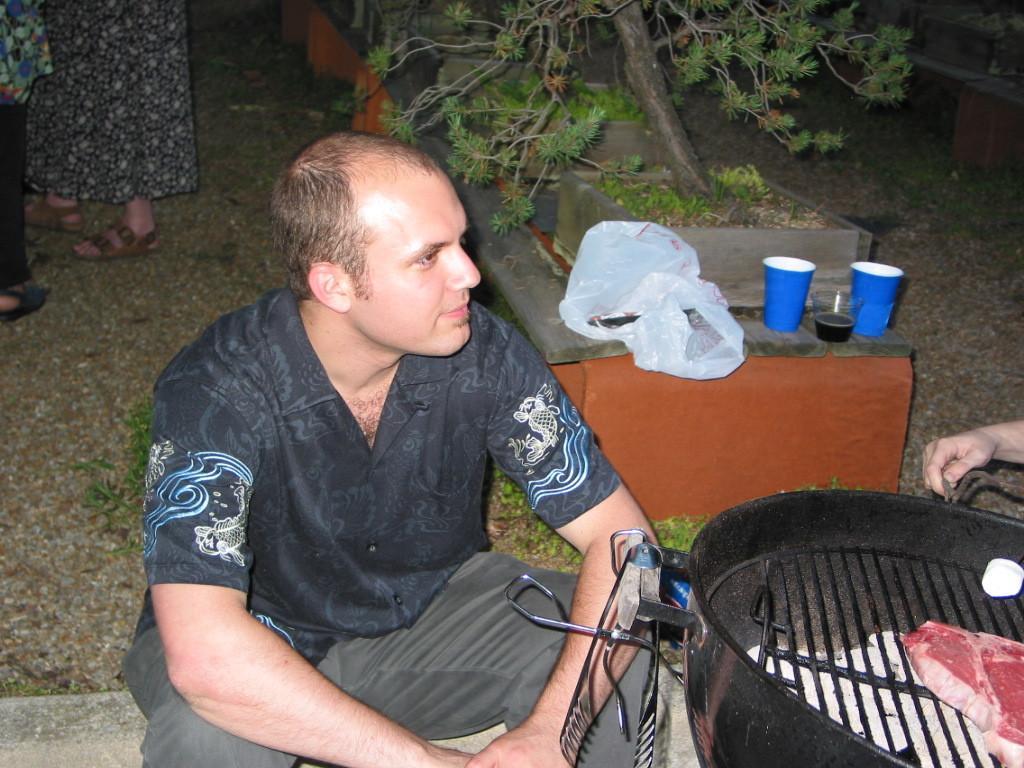How would you summarize this image in a sentence or two? There is a man in the center of the image and there is a meat on the grill in the bottom right side and there are glasses, plants, people and polythene in the background area, there is another person on the right side. 